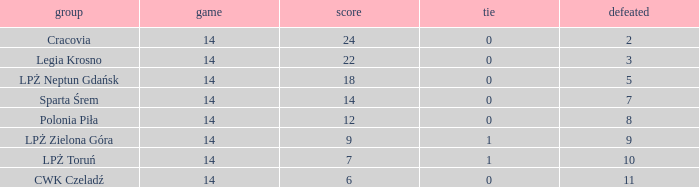What is the sum for the match with a draw less than 0? None. 